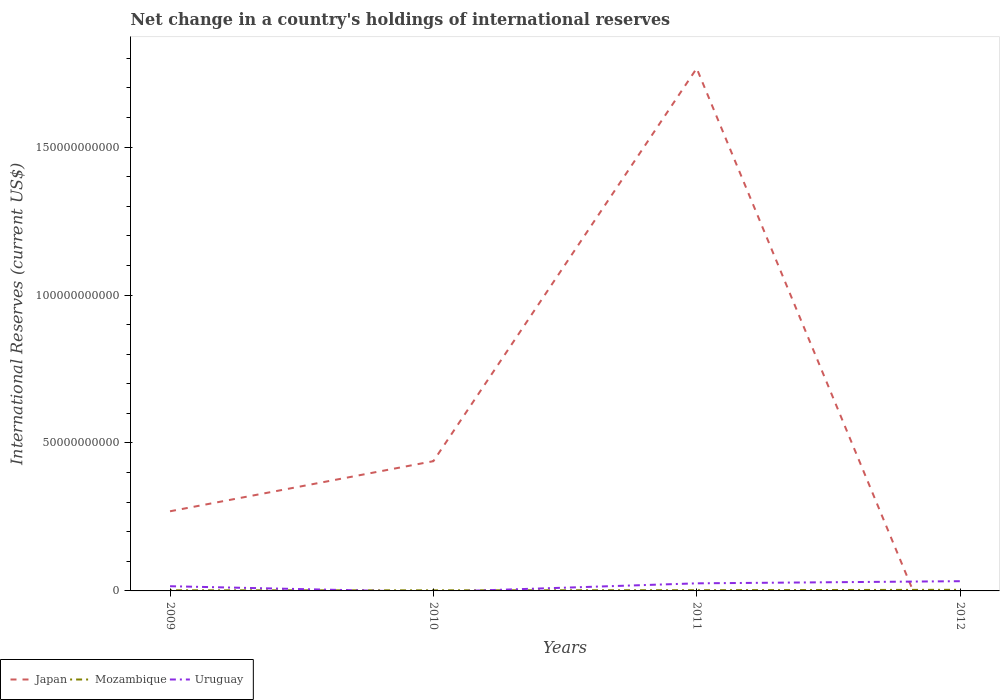How many different coloured lines are there?
Ensure brevity in your answer.  3. Across all years, what is the maximum international reserves in Mozambique?
Your answer should be compact. 2.01e+08. What is the total international reserves in Japan in the graph?
Your answer should be very brief. -1.33e+11. What is the difference between the highest and the second highest international reserves in Uruguay?
Ensure brevity in your answer.  3.29e+09. Is the international reserves in Japan strictly greater than the international reserves in Mozambique over the years?
Provide a succinct answer. No. How many years are there in the graph?
Your answer should be very brief. 4. Are the values on the major ticks of Y-axis written in scientific E-notation?
Offer a very short reply. No. Does the graph contain any zero values?
Give a very brief answer. Yes. How many legend labels are there?
Your answer should be compact. 3. How are the legend labels stacked?
Your answer should be compact. Horizontal. What is the title of the graph?
Provide a succinct answer. Net change in a country's holdings of international reserves. Does "El Salvador" appear as one of the legend labels in the graph?
Provide a short and direct response. No. What is the label or title of the Y-axis?
Keep it short and to the point. International Reserves (current US$). What is the International Reserves (current US$) of Japan in 2009?
Your response must be concise. 2.69e+1. What is the International Reserves (current US$) of Mozambique in 2009?
Offer a terse response. 2.10e+08. What is the International Reserves (current US$) in Uruguay in 2009?
Provide a short and direct response. 1.59e+09. What is the International Reserves (current US$) in Japan in 2010?
Your answer should be very brief. 4.39e+1. What is the International Reserves (current US$) in Mozambique in 2010?
Make the answer very short. 2.01e+08. What is the International Reserves (current US$) in Uruguay in 2010?
Offer a very short reply. 0. What is the International Reserves (current US$) in Japan in 2011?
Provide a succinct answer. 1.77e+11. What is the International Reserves (current US$) in Mozambique in 2011?
Keep it short and to the point. 2.44e+08. What is the International Reserves (current US$) in Uruguay in 2011?
Ensure brevity in your answer.  2.56e+09. What is the International Reserves (current US$) in Japan in 2012?
Ensure brevity in your answer.  0. What is the International Reserves (current US$) of Mozambique in 2012?
Provide a short and direct response. 3.77e+08. What is the International Reserves (current US$) of Uruguay in 2012?
Keep it short and to the point. 3.29e+09. Across all years, what is the maximum International Reserves (current US$) of Japan?
Provide a succinct answer. 1.77e+11. Across all years, what is the maximum International Reserves (current US$) in Mozambique?
Offer a very short reply. 3.77e+08. Across all years, what is the maximum International Reserves (current US$) in Uruguay?
Provide a succinct answer. 3.29e+09. Across all years, what is the minimum International Reserves (current US$) in Japan?
Your answer should be very brief. 0. Across all years, what is the minimum International Reserves (current US$) in Mozambique?
Provide a succinct answer. 2.01e+08. Across all years, what is the minimum International Reserves (current US$) of Uruguay?
Keep it short and to the point. 0. What is the total International Reserves (current US$) in Japan in the graph?
Your response must be concise. 2.47e+11. What is the total International Reserves (current US$) of Mozambique in the graph?
Your answer should be compact. 1.03e+09. What is the total International Reserves (current US$) of Uruguay in the graph?
Keep it short and to the point. 7.44e+09. What is the difference between the International Reserves (current US$) of Japan in 2009 and that in 2010?
Offer a very short reply. -1.69e+1. What is the difference between the International Reserves (current US$) in Mozambique in 2009 and that in 2010?
Your answer should be compact. 8.73e+06. What is the difference between the International Reserves (current US$) of Japan in 2009 and that in 2011?
Your answer should be compact. -1.50e+11. What is the difference between the International Reserves (current US$) in Mozambique in 2009 and that in 2011?
Provide a short and direct response. -3.39e+07. What is the difference between the International Reserves (current US$) of Uruguay in 2009 and that in 2011?
Offer a terse response. -9.77e+08. What is the difference between the International Reserves (current US$) of Mozambique in 2009 and that in 2012?
Provide a short and direct response. -1.68e+08. What is the difference between the International Reserves (current US$) in Uruguay in 2009 and that in 2012?
Ensure brevity in your answer.  -1.70e+09. What is the difference between the International Reserves (current US$) of Japan in 2010 and that in 2011?
Offer a very short reply. -1.33e+11. What is the difference between the International Reserves (current US$) of Mozambique in 2010 and that in 2011?
Offer a terse response. -4.26e+07. What is the difference between the International Reserves (current US$) in Mozambique in 2010 and that in 2012?
Your response must be concise. -1.76e+08. What is the difference between the International Reserves (current US$) in Mozambique in 2011 and that in 2012?
Your response must be concise. -1.34e+08. What is the difference between the International Reserves (current US$) of Uruguay in 2011 and that in 2012?
Make the answer very short. -7.23e+08. What is the difference between the International Reserves (current US$) of Japan in 2009 and the International Reserves (current US$) of Mozambique in 2010?
Your answer should be compact. 2.67e+1. What is the difference between the International Reserves (current US$) in Japan in 2009 and the International Reserves (current US$) in Mozambique in 2011?
Your answer should be compact. 2.67e+1. What is the difference between the International Reserves (current US$) in Japan in 2009 and the International Reserves (current US$) in Uruguay in 2011?
Your answer should be very brief. 2.44e+1. What is the difference between the International Reserves (current US$) of Mozambique in 2009 and the International Reserves (current US$) of Uruguay in 2011?
Make the answer very short. -2.35e+09. What is the difference between the International Reserves (current US$) of Japan in 2009 and the International Reserves (current US$) of Mozambique in 2012?
Offer a very short reply. 2.65e+1. What is the difference between the International Reserves (current US$) of Japan in 2009 and the International Reserves (current US$) of Uruguay in 2012?
Give a very brief answer. 2.36e+1. What is the difference between the International Reserves (current US$) of Mozambique in 2009 and the International Reserves (current US$) of Uruguay in 2012?
Your answer should be compact. -3.08e+09. What is the difference between the International Reserves (current US$) in Japan in 2010 and the International Reserves (current US$) in Mozambique in 2011?
Your response must be concise. 4.36e+1. What is the difference between the International Reserves (current US$) of Japan in 2010 and the International Reserves (current US$) of Uruguay in 2011?
Your answer should be very brief. 4.13e+1. What is the difference between the International Reserves (current US$) of Mozambique in 2010 and the International Reserves (current US$) of Uruguay in 2011?
Give a very brief answer. -2.36e+09. What is the difference between the International Reserves (current US$) of Japan in 2010 and the International Reserves (current US$) of Mozambique in 2012?
Ensure brevity in your answer.  4.35e+1. What is the difference between the International Reserves (current US$) in Japan in 2010 and the International Reserves (current US$) in Uruguay in 2012?
Give a very brief answer. 4.06e+1. What is the difference between the International Reserves (current US$) in Mozambique in 2010 and the International Reserves (current US$) in Uruguay in 2012?
Keep it short and to the point. -3.09e+09. What is the difference between the International Reserves (current US$) in Japan in 2011 and the International Reserves (current US$) in Mozambique in 2012?
Give a very brief answer. 1.76e+11. What is the difference between the International Reserves (current US$) of Japan in 2011 and the International Reserves (current US$) of Uruguay in 2012?
Give a very brief answer. 1.73e+11. What is the difference between the International Reserves (current US$) of Mozambique in 2011 and the International Reserves (current US$) of Uruguay in 2012?
Provide a succinct answer. -3.04e+09. What is the average International Reserves (current US$) of Japan per year?
Provide a succinct answer. 6.18e+1. What is the average International Reserves (current US$) of Mozambique per year?
Keep it short and to the point. 2.58e+08. What is the average International Reserves (current US$) in Uruguay per year?
Give a very brief answer. 1.86e+09. In the year 2009, what is the difference between the International Reserves (current US$) in Japan and International Reserves (current US$) in Mozambique?
Keep it short and to the point. 2.67e+1. In the year 2009, what is the difference between the International Reserves (current US$) in Japan and International Reserves (current US$) in Uruguay?
Your answer should be compact. 2.53e+1. In the year 2009, what is the difference between the International Reserves (current US$) of Mozambique and International Reserves (current US$) of Uruguay?
Provide a short and direct response. -1.38e+09. In the year 2010, what is the difference between the International Reserves (current US$) in Japan and International Reserves (current US$) in Mozambique?
Your answer should be compact. 4.37e+1. In the year 2011, what is the difference between the International Reserves (current US$) in Japan and International Reserves (current US$) in Mozambique?
Your answer should be compact. 1.76e+11. In the year 2011, what is the difference between the International Reserves (current US$) of Japan and International Reserves (current US$) of Uruguay?
Offer a terse response. 1.74e+11. In the year 2011, what is the difference between the International Reserves (current US$) of Mozambique and International Reserves (current US$) of Uruguay?
Your response must be concise. -2.32e+09. In the year 2012, what is the difference between the International Reserves (current US$) in Mozambique and International Reserves (current US$) in Uruguay?
Your answer should be very brief. -2.91e+09. What is the ratio of the International Reserves (current US$) in Japan in 2009 to that in 2010?
Make the answer very short. 0.61. What is the ratio of the International Reserves (current US$) in Mozambique in 2009 to that in 2010?
Give a very brief answer. 1.04. What is the ratio of the International Reserves (current US$) of Japan in 2009 to that in 2011?
Give a very brief answer. 0.15. What is the ratio of the International Reserves (current US$) of Mozambique in 2009 to that in 2011?
Keep it short and to the point. 0.86. What is the ratio of the International Reserves (current US$) in Uruguay in 2009 to that in 2011?
Ensure brevity in your answer.  0.62. What is the ratio of the International Reserves (current US$) in Mozambique in 2009 to that in 2012?
Keep it short and to the point. 0.56. What is the ratio of the International Reserves (current US$) in Uruguay in 2009 to that in 2012?
Provide a short and direct response. 0.48. What is the ratio of the International Reserves (current US$) of Japan in 2010 to that in 2011?
Ensure brevity in your answer.  0.25. What is the ratio of the International Reserves (current US$) of Mozambique in 2010 to that in 2011?
Provide a short and direct response. 0.83. What is the ratio of the International Reserves (current US$) in Mozambique in 2010 to that in 2012?
Provide a short and direct response. 0.53. What is the ratio of the International Reserves (current US$) of Mozambique in 2011 to that in 2012?
Keep it short and to the point. 0.65. What is the ratio of the International Reserves (current US$) in Uruguay in 2011 to that in 2012?
Your answer should be very brief. 0.78. What is the difference between the highest and the second highest International Reserves (current US$) of Japan?
Your response must be concise. 1.33e+11. What is the difference between the highest and the second highest International Reserves (current US$) in Mozambique?
Give a very brief answer. 1.34e+08. What is the difference between the highest and the second highest International Reserves (current US$) of Uruguay?
Your answer should be compact. 7.23e+08. What is the difference between the highest and the lowest International Reserves (current US$) in Japan?
Provide a short and direct response. 1.77e+11. What is the difference between the highest and the lowest International Reserves (current US$) of Mozambique?
Your answer should be compact. 1.76e+08. What is the difference between the highest and the lowest International Reserves (current US$) in Uruguay?
Make the answer very short. 3.29e+09. 